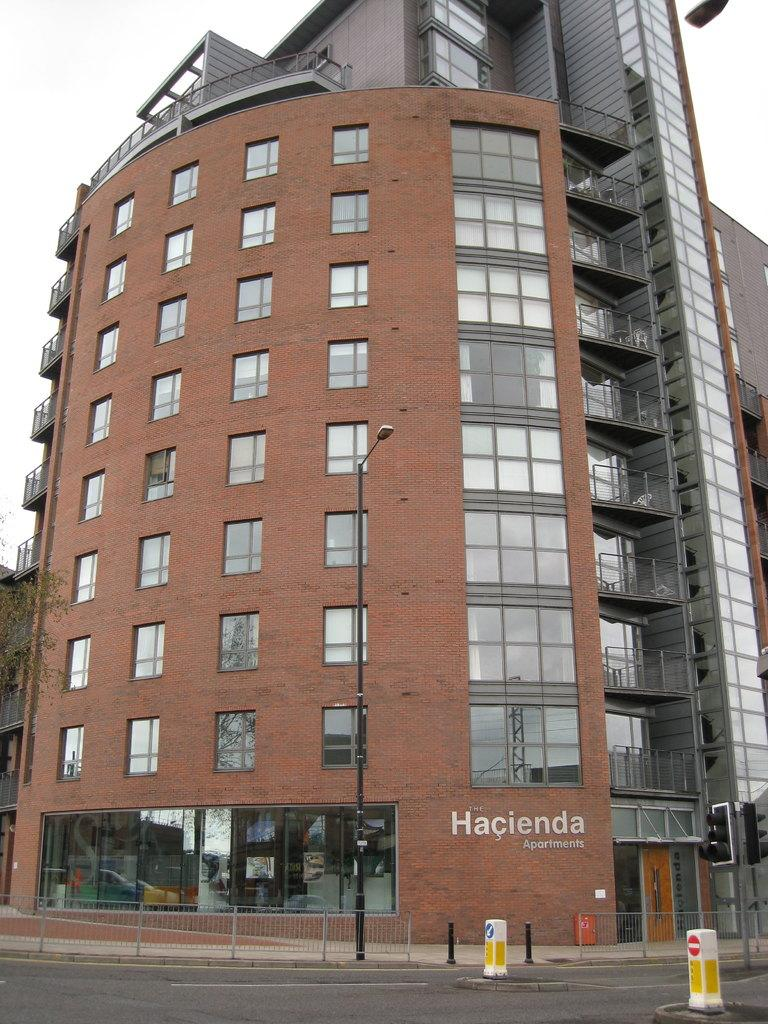<image>
Give a short and clear explanation of the subsequent image. A tall brick building called The Hacienda Apartments 